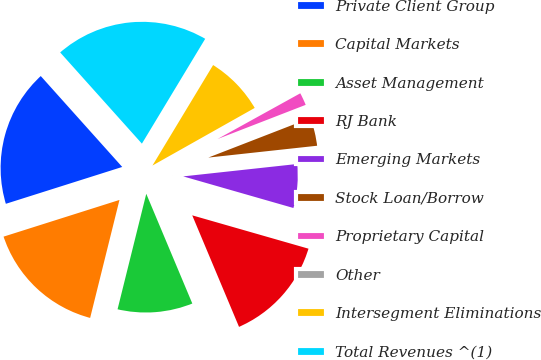Convert chart to OTSL. <chart><loc_0><loc_0><loc_500><loc_500><pie_chart><fcel>Private Client Group<fcel>Capital Markets<fcel>Asset Management<fcel>RJ Bank<fcel>Emerging Markets<fcel>Stock Loan/Borrow<fcel>Proprietary Capital<fcel>Other<fcel>Intersegment Eliminations<fcel>Total Revenues ^(1)<nl><fcel>18.25%<fcel>16.24%<fcel>10.2%<fcel>14.23%<fcel>6.17%<fcel>4.16%<fcel>2.15%<fcel>0.13%<fcel>8.19%<fcel>20.27%<nl></chart> 